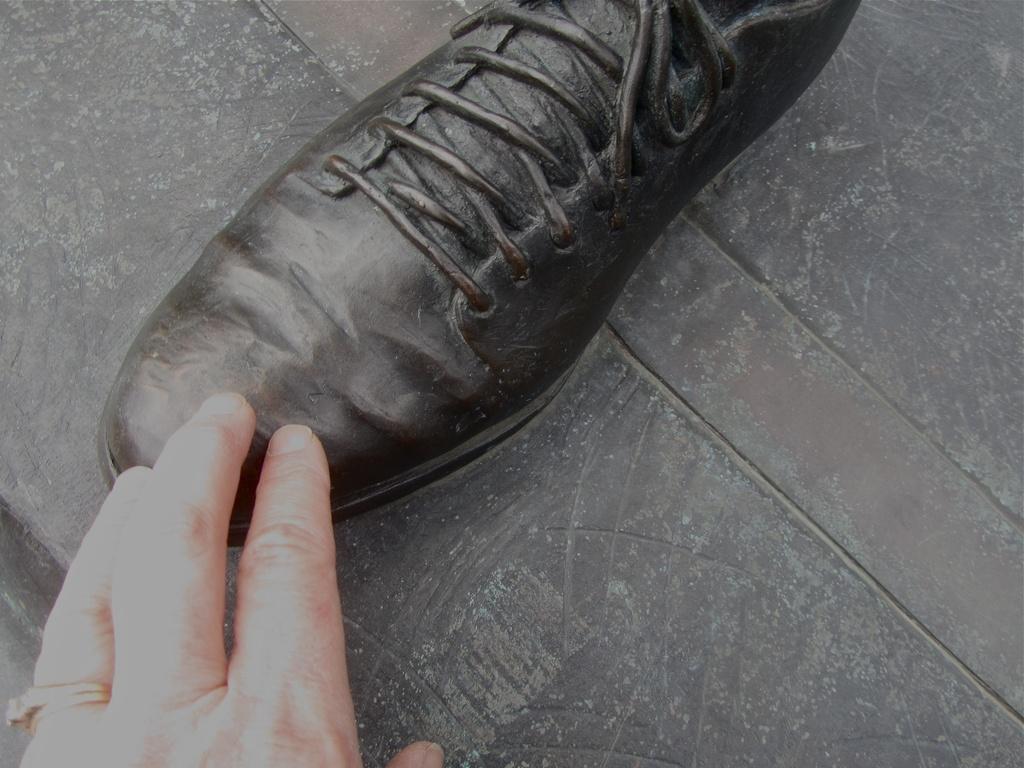Could you give a brief overview of what you see in this image? In this image I can see depiction of a shoe and here I can see hand of a person. I can also see a ring on his finger. 